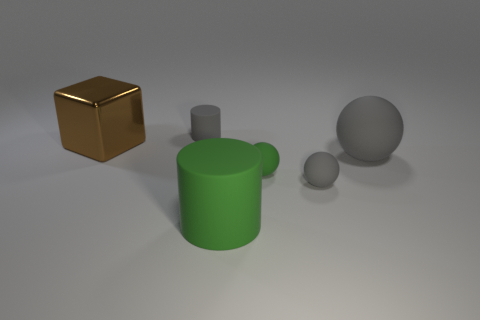Subtract all big matte spheres. How many spheres are left? 2 Subtract 1 balls. How many balls are left? 2 Add 1 small gray objects. How many objects exist? 7 Subtract all cylinders. How many objects are left? 4 Subtract all tiny matte balls. Subtract all tiny spheres. How many objects are left? 2 Add 1 green balls. How many green balls are left? 2 Add 3 small gray matte things. How many small gray matte things exist? 5 Subtract 1 green spheres. How many objects are left? 5 